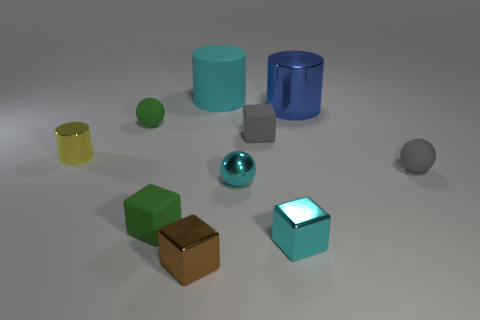Subtract 1 cubes. How many cubes are left? 3 Subtract all yellow blocks. Subtract all green cylinders. How many blocks are left? 4 Subtract all cylinders. How many objects are left? 7 Subtract 1 yellow cylinders. How many objects are left? 9 Subtract all tiny cyan spheres. Subtract all blue matte spheres. How many objects are left? 9 Add 2 green objects. How many green objects are left? 4 Add 5 big shiny objects. How many big shiny objects exist? 6 